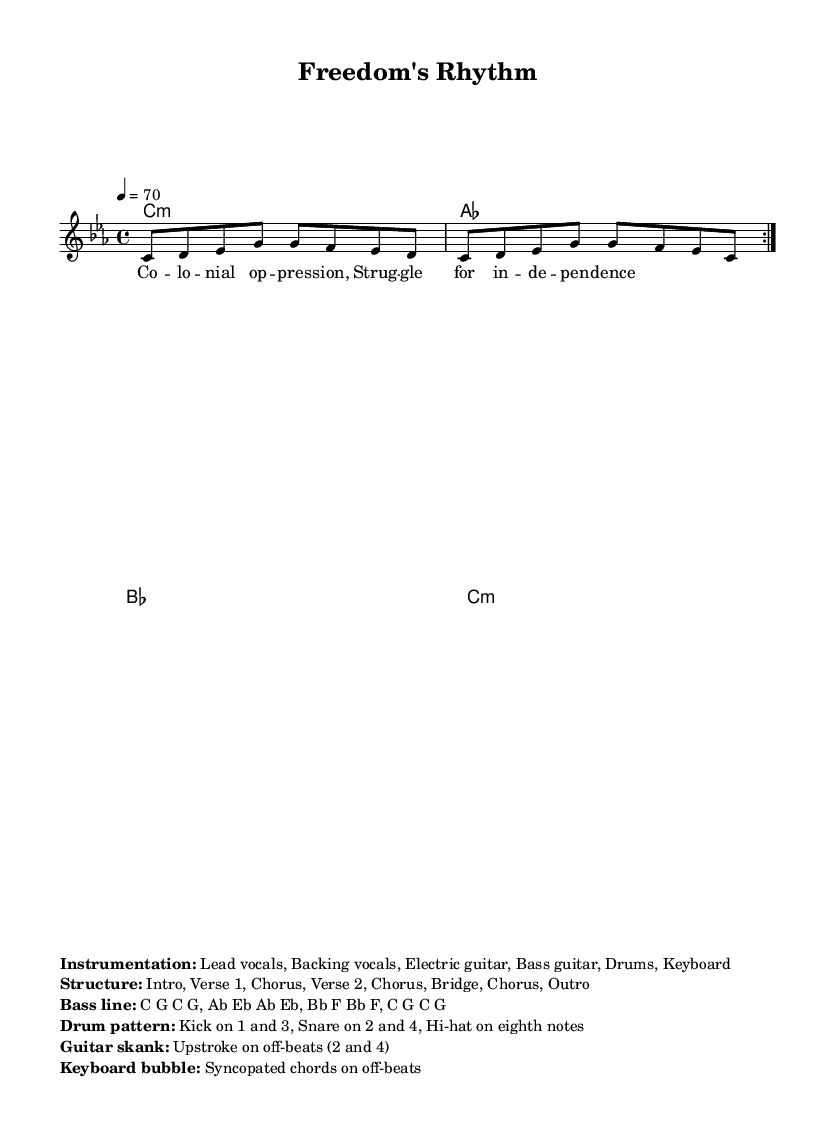What is the key signature of this music? The key signature is C minor, which is indicated by the flat symbols present on the B note. Since there are three flats (B, E, and A), it establishes the piece in C minor.
Answer: C minor What is the time signature of this music? The time signature is given in the measure part at the beginning of the score, which indicates the number of beats in a measure and the note value that gets the beat. The 4/4 time signature means there are four beats per measure, with the quarter note receiving one beat.
Answer: 4/4 What is the tempo marking of this music? The tempo marking is specified in the score, indicated as "4 = 70," meaning the quarter note is played at a speed of 70 beats per minute. Hence, it conveys the performance speed for musicians.
Answer: 70 What is the primary theme reflected in the lyrics? The lyrics highlight themes of colonial oppression and the struggle for independence. By examining the lyric text, we can see key phrases such as "Colonial oppression" and "Struggle for independence," which capture the essence of the song.
Answer: Colonial oppression How many instruments are indicated in the instrumentation section? The instrumentation section specifies a total of six instruments: Lead vocals, Backing vocals, Electric guitar, Bass guitar, Drums, and Keyboard. This can be counted directly from the listed instruments under the "Instrumentation" heading, confirming their presence in the arrangement.
Answer: Six What is the structure of the song? The structure is outlined in the sheet music, breaking down into sections such as Intro, Verse 1, Chorus, Verse 2, Chorus, Bridge, Chorus, and Outro. This delineation presents the layout and organization of the piece, which is essential for performers.
Answer: Intro, Verse 1, Chorus, Verse 2, Chorus, Bridge, Chorus, Outro 